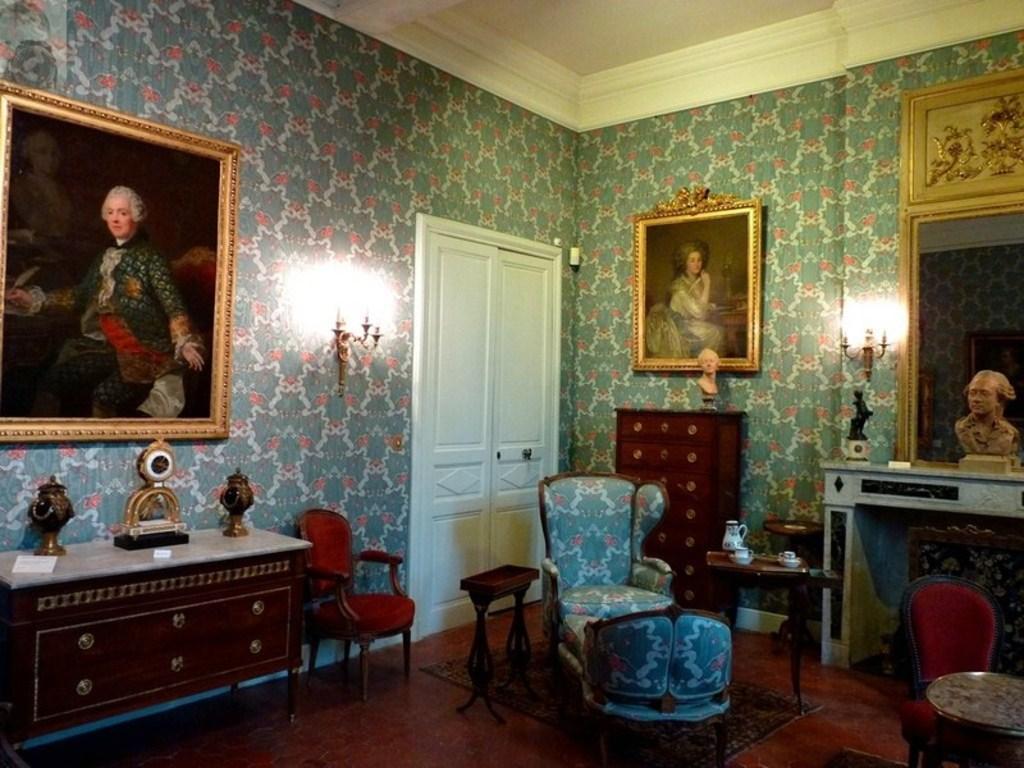Can you describe this image briefly? In this image I can see a room with blue chairs. To the left there is a table. On the table there are some objects and to the right there are cups and a flask. In the back there are frames attached to the wall and a light. I can also see a statue to the right. 